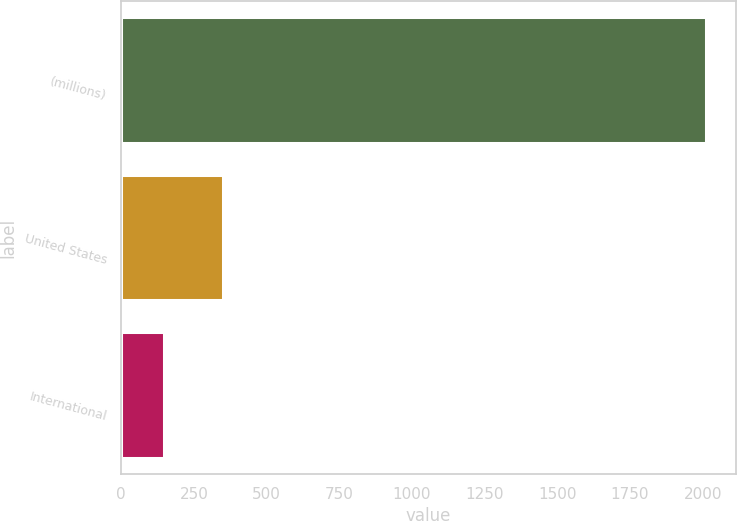Convert chart. <chart><loc_0><loc_0><loc_500><loc_500><bar_chart><fcel>(millions)<fcel>United States<fcel>International<nl><fcel>2013<fcel>351.2<fcel>148.2<nl></chart> 